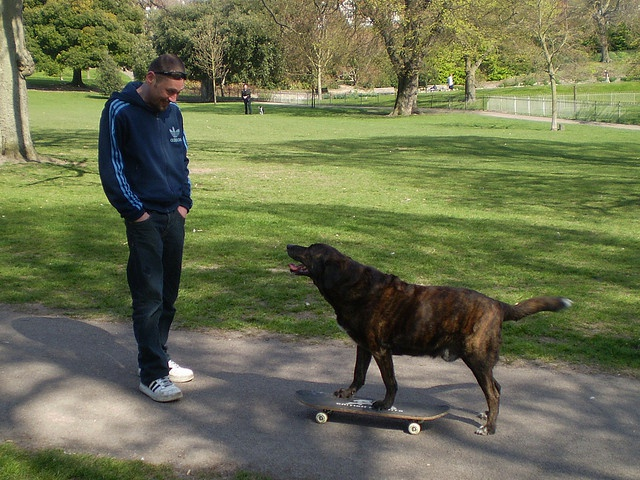Describe the objects in this image and their specific colors. I can see people in tan, black, navy, gray, and darkblue tones, dog in tan, black, maroon, and gray tones, skateboard in tan, gray, and black tones, people in tan, black, gray, maroon, and darkgreen tones, and people in tan, ivory, darkgray, and gray tones in this image. 